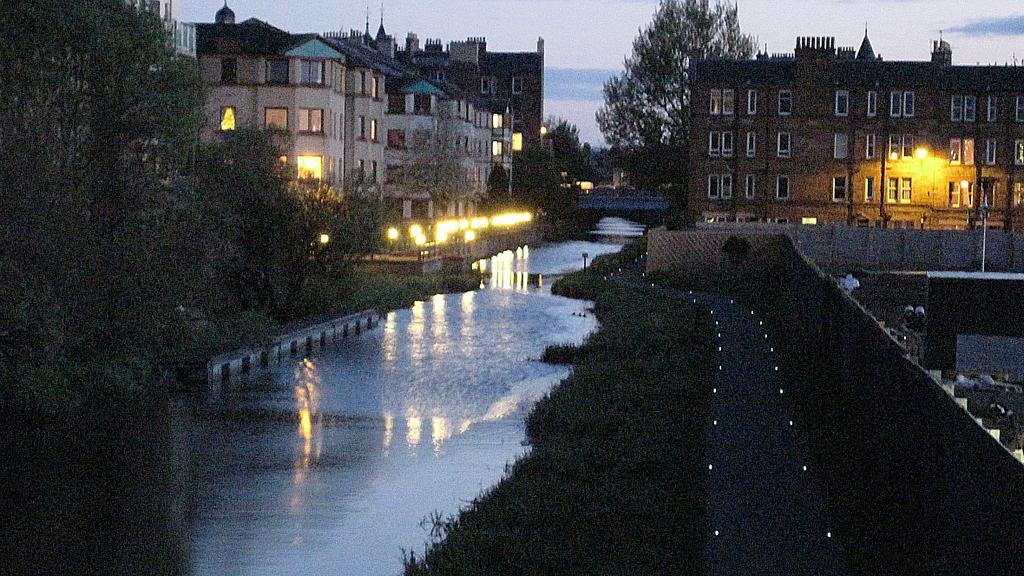Can you describe this image briefly? In this image, on the right side, we can see a building, windows, wall, plants. On the left side, we can see some trees, plants, building, windows, lights. In the middle of the image, we can see water in a lake. In the background, we can see a bridge, trees. At the top, we can see a sky which is cloudy, at the bottom, we can see a grass. 